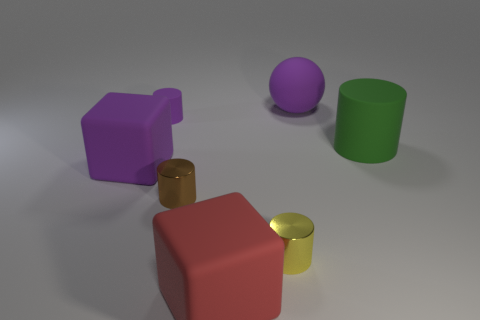There is a matte block behind the big red object; does it have the same color as the big sphere?
Make the answer very short. Yes. What number of purple things are tiny rubber cylinders or big spheres?
Keep it short and to the point. 2. There is a metal thing behind the shiny cylinder on the right side of the large red matte object; what color is it?
Offer a very short reply. Brown. What material is the small object that is the same color as the big sphere?
Your response must be concise. Rubber. What is the color of the rubber cube on the right side of the purple matte cylinder?
Offer a very short reply. Red. There is a purple rubber object that is on the right side of the yellow metallic cylinder; does it have the same size as the purple block?
Your answer should be very brief. Yes. There is a block that is the same color as the ball; what size is it?
Keep it short and to the point. Large. Are there any matte spheres of the same size as the red thing?
Provide a succinct answer. Yes. There is a big matte cube that is left of the red object; is its color the same as the small rubber object that is behind the large purple block?
Ensure brevity in your answer.  Yes. Is there a large sphere of the same color as the tiny matte object?
Your answer should be very brief. Yes. 